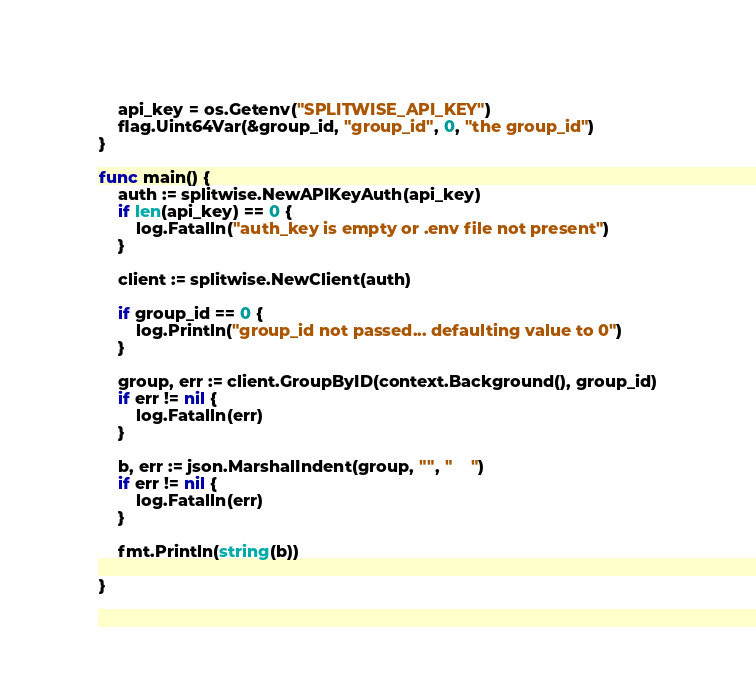Convert code to text. <code><loc_0><loc_0><loc_500><loc_500><_Go_>	api_key = os.Getenv("SPLITWISE_API_KEY")
	flag.Uint64Var(&group_id, "group_id", 0, "the group_id")
}

func main() {
	auth := splitwise.NewAPIKeyAuth(api_key)
	if len(api_key) == 0 {
		log.Fatalln("auth_key is empty or .env file not present")
	}

	client := splitwise.NewClient(auth)

	if group_id == 0 {
		log.Println("group_id not passed... defaulting value to 0")
	}

	group, err := client.GroupByID(context.Background(), group_id)
	if err != nil {
		log.Fatalln(err)
	}

	b, err := json.MarshalIndent(group, "", "    ")
	if err != nil {
		log.Fatalln(err)
	}

	fmt.Println(string(b))

}
</code> 